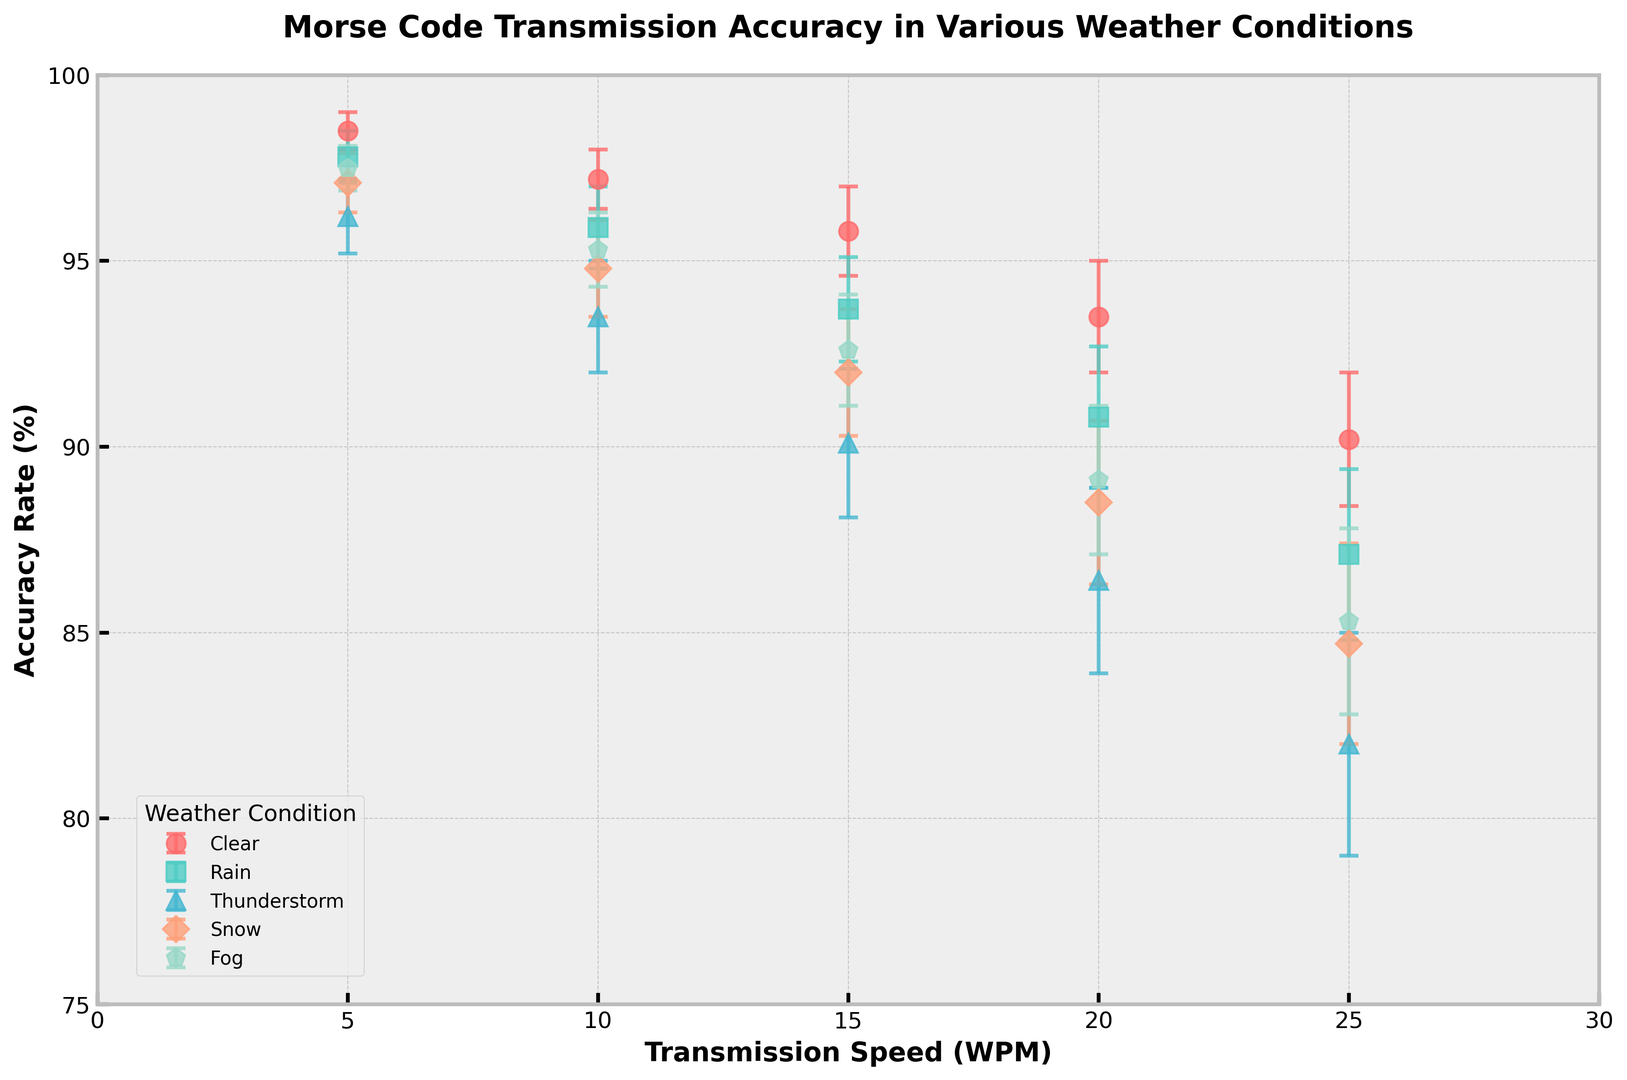Which weather condition has the highest accuracy rate at 5 WPM? To determine this, locate the data points for each weather condition at 5 WPM on the x-axis and compare their accuracy rates on the y-axis. The highest accuracy rate is seen under the 'Clear' condition.
Answer: Clear Which transmission speed shows the largest drop in accuracy rate for Thunderstorm conditions? Identify the accuracy rates for each transmission speed under Thunderstorm conditions, and calculate the differences between successive speeds. The largest drop is between 20 WPM and 25 WPM (86.4% to 82.0%).
Answer: From 20 WPM to 25 WPM What's the average accuracy rate across all weather conditions at 10 WPM? For 10 WPM, find the accuracy rates for all weather conditions: Clear (97.2), Rain (95.9), Thunderstorm (93.5), Snow (94.8), Fog (95.3). Sum these values and divide by the number of conditions (5). The average is (97.2 + 95.9 + 93.5 + 94.8 + 95.3) / 5 = 95.34%.
Answer: 95.34% At what speed does the accuracy rate for Fog conditions first drop below 90%? Analyze the accuracy rates for Fog conditions at each speed and identify where it first dips below 90%. It drops to 89.1% at 20 WPM.
Answer: 20 WPM Which weather condition shows the least variability in accuracy rates across different transmission speeds? Variability can be assessed by comparing the error margins for each weather condition. The smallest range of error margins is observed for 'Clear' conditions, indicating the least variability.
Answer: Clear Which two transmission speeds have the closest accuracy rates under Snow conditions? Locate the accuracy rates for Snow conditions at each speed: 97.1 (5 WPM), 94.8 (10 WPM), 92.0 (15 WPM), 88.5 (20 WPM), 84.7 (25 WPM). The closest rates are at 10 WPM (94.8) and 15 WPM (92.0).
Answer: 10 WPM and 15 WPM How much greater is the average accuracy rate in Clear conditions compared to Thunderstorm conditions? Compute the average rates: Clear (97.0+97.2+95.8+93.5+90.2)/5 = 95.04%; Thunderstorm (96.2+93.5+90.1+86.4+82.0)/5 = 89.64%. Subtract the averages: 95.04% - 89.64% = 5.4%.
Answer: 5.4% Which weather condition has the smallest accuracy rate at 20 WPM? Compare the accuracy rates for all weather conditions at 20 WPM. The smallest accuracy rate is observed under 'Thunderstorm' conditions, which is 86.4%.
Answer: Thunderstorm What is the overall trend in accuracy rates as transmission speed increases? Observing all conditions, the general trend shows that accuracy rates decrease as transmission speed increases from 5 WPM to 25 WPM, regardless of the weather condition.
Answer: Decreases 